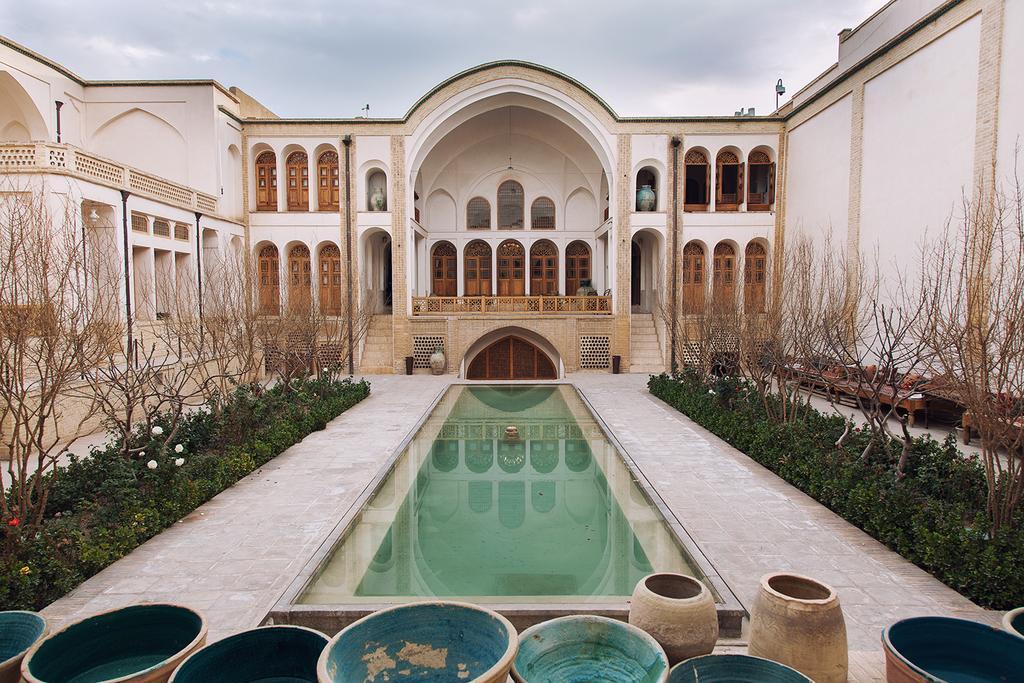Describe this image in one or two sentences. In this image there is a building and we can see trees. At the bottom there are vases and we can see pots. There are flowers and shrubs. There is a pool. In the background we can see the sky. 